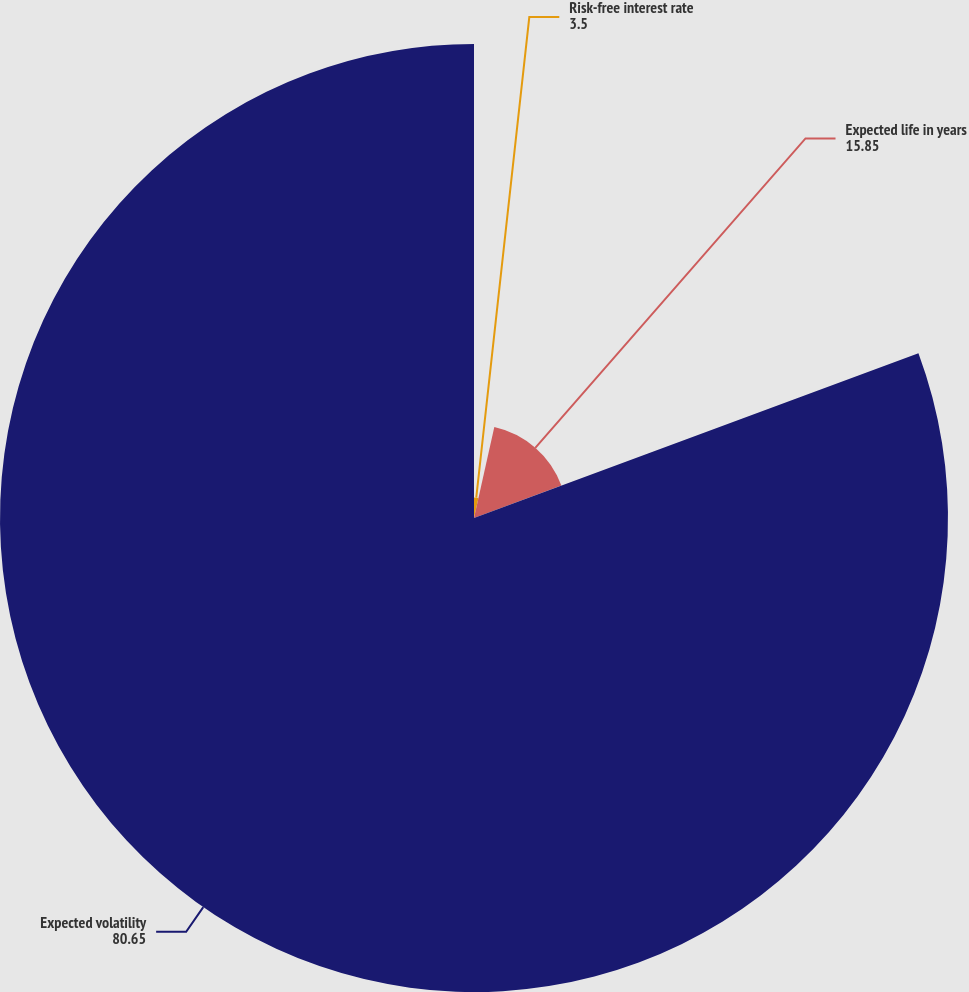Convert chart to OTSL. <chart><loc_0><loc_0><loc_500><loc_500><pie_chart><fcel>Risk-free interest rate<fcel>Expected life in years<fcel>Expected volatility<nl><fcel>3.5%<fcel>15.85%<fcel>80.65%<nl></chart> 